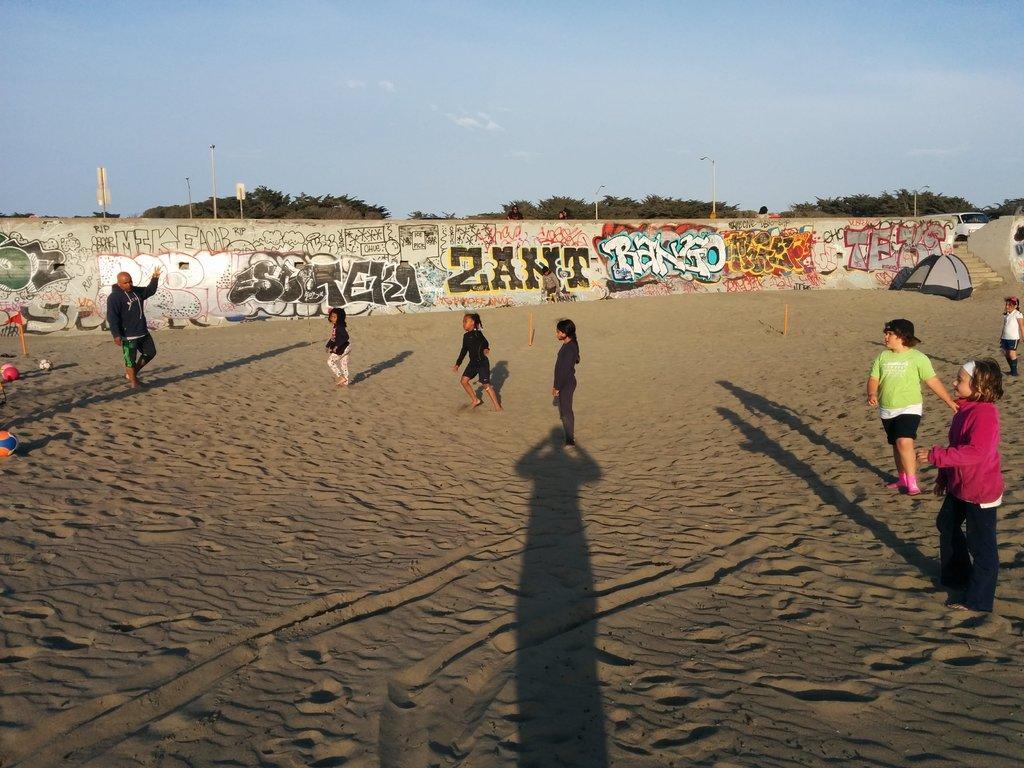Describe this image in one or two sentences. In the picture I can see people are standing on the ground. I can also see balls and some other objects on the ground. In the background I can see a wall which has something painted on it. I can also see trees, poles, the sky and some other objects. 